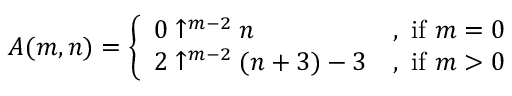<formula> <loc_0><loc_0><loc_500><loc_500>A ( m , n ) = { \left \{ \begin{array} { l l } { 0 \uparrow ^ { m - 2 } n } & { { , i f } m = 0 } \\ { 2 \uparrow ^ { m - 2 } ( n + 3 ) - 3 } & { { , i f } m > 0 } \end{array} }</formula> 